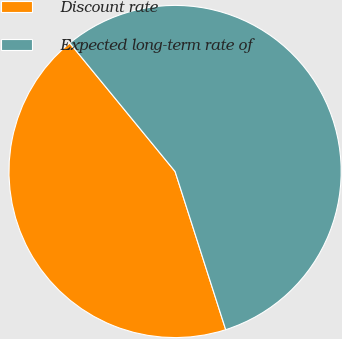<chart> <loc_0><loc_0><loc_500><loc_500><pie_chart><fcel>Discount rate<fcel>Expected long-term rate of<nl><fcel>44.0%<fcel>56.0%<nl></chart> 